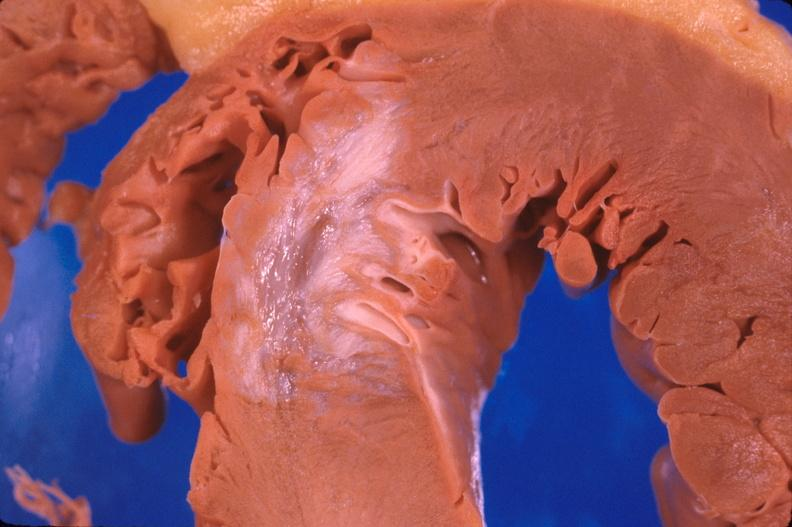where is this?
Answer the question using a single word or phrase. Heart 